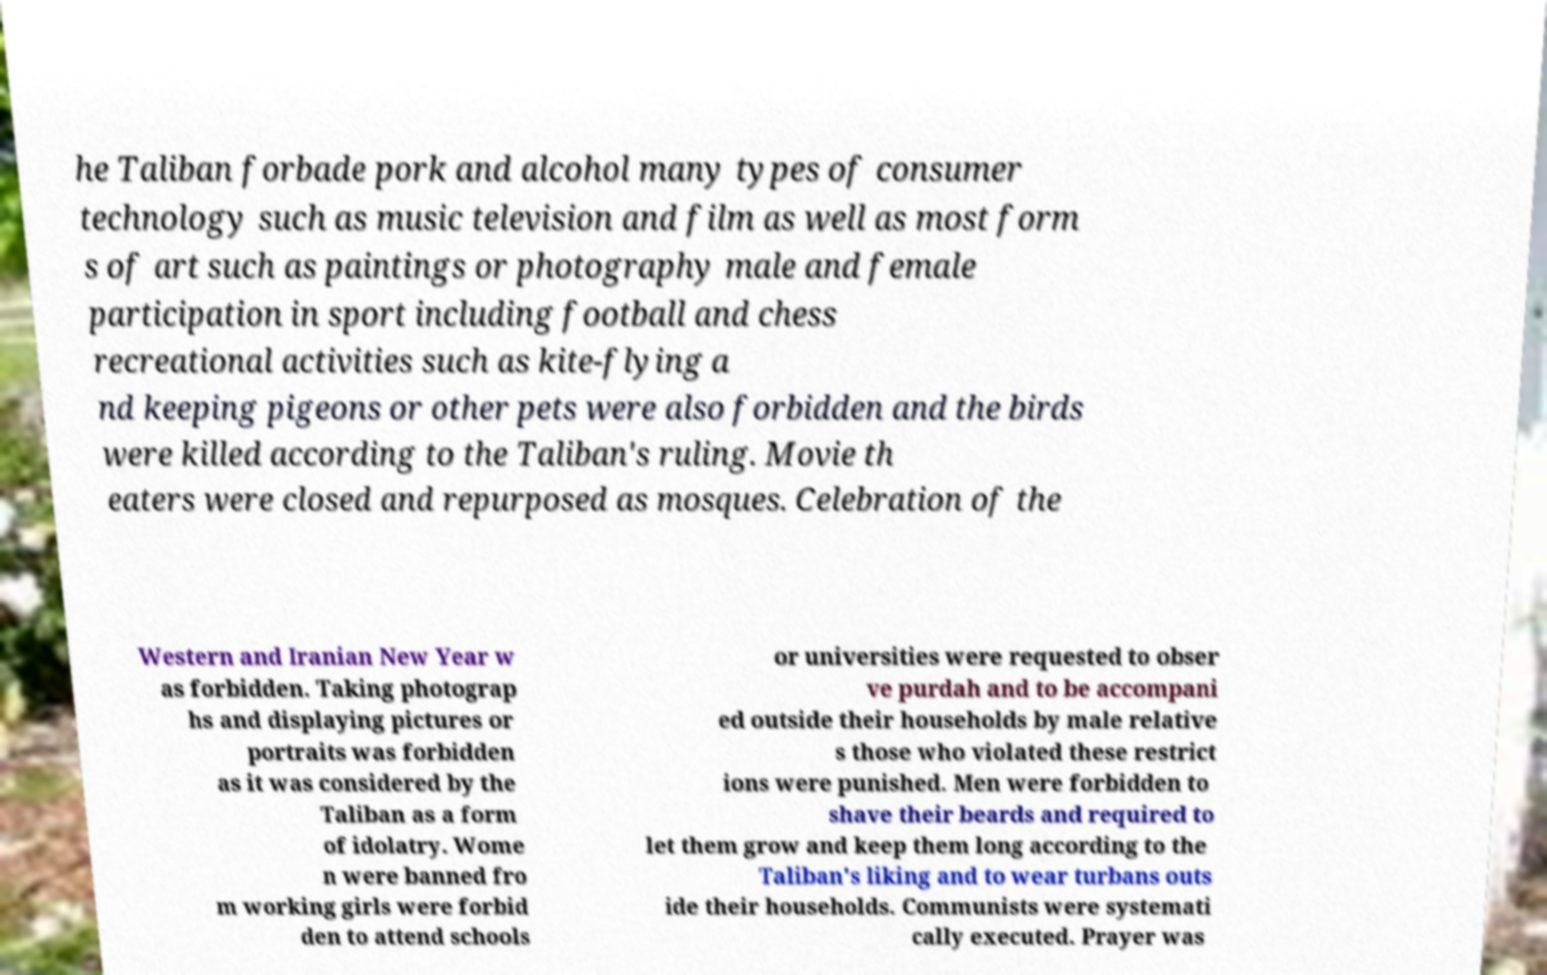Can you read and provide the text displayed in the image?This photo seems to have some interesting text. Can you extract and type it out for me? he Taliban forbade pork and alcohol many types of consumer technology such as music television and film as well as most form s of art such as paintings or photography male and female participation in sport including football and chess recreational activities such as kite-flying a nd keeping pigeons or other pets were also forbidden and the birds were killed according to the Taliban's ruling. Movie th eaters were closed and repurposed as mosques. Celebration of the Western and Iranian New Year w as forbidden. Taking photograp hs and displaying pictures or portraits was forbidden as it was considered by the Taliban as a form of idolatry. Wome n were banned fro m working girls were forbid den to attend schools or universities were requested to obser ve purdah and to be accompani ed outside their households by male relative s those who violated these restrict ions were punished. Men were forbidden to shave their beards and required to let them grow and keep them long according to the Taliban's liking and to wear turbans outs ide their households. Communists were systemati cally executed. Prayer was 